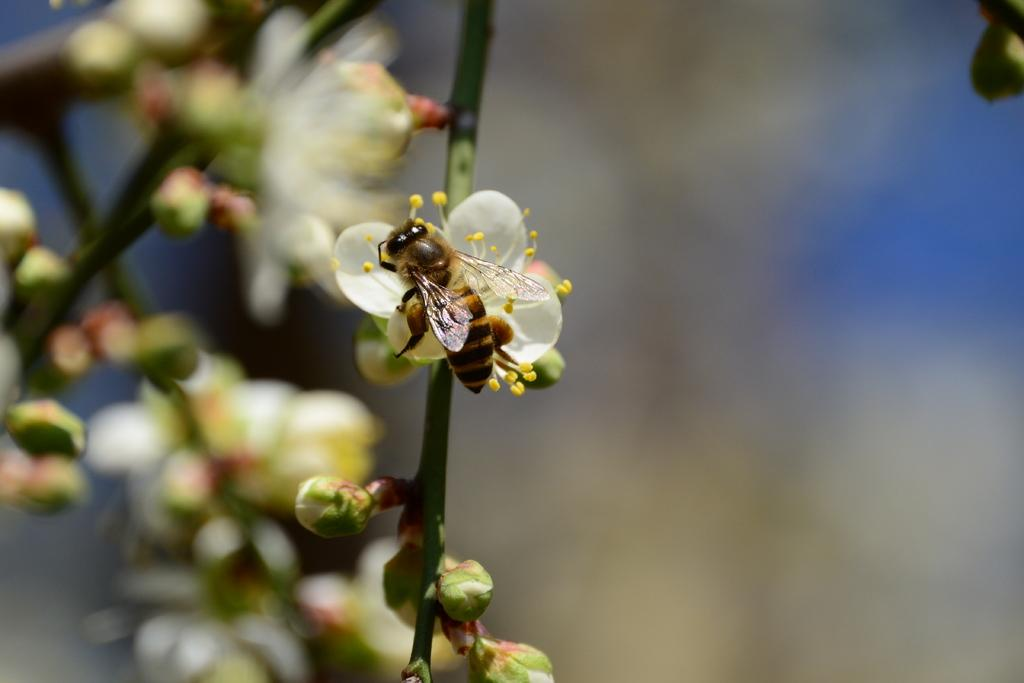What type of insect is in the image? There is a honey bee in the image. What is the honey bee doing in the image? The honey bee is on a flower. What color is the flower the honey bee is on? The flower is white. What can be seen in the background of the image? There are blurred flowers in the background of the image. How does the honey bee experience the ink on the flower in the image? There is no ink present on the flower in the image, as it is a white flower with a honey bee on it. 